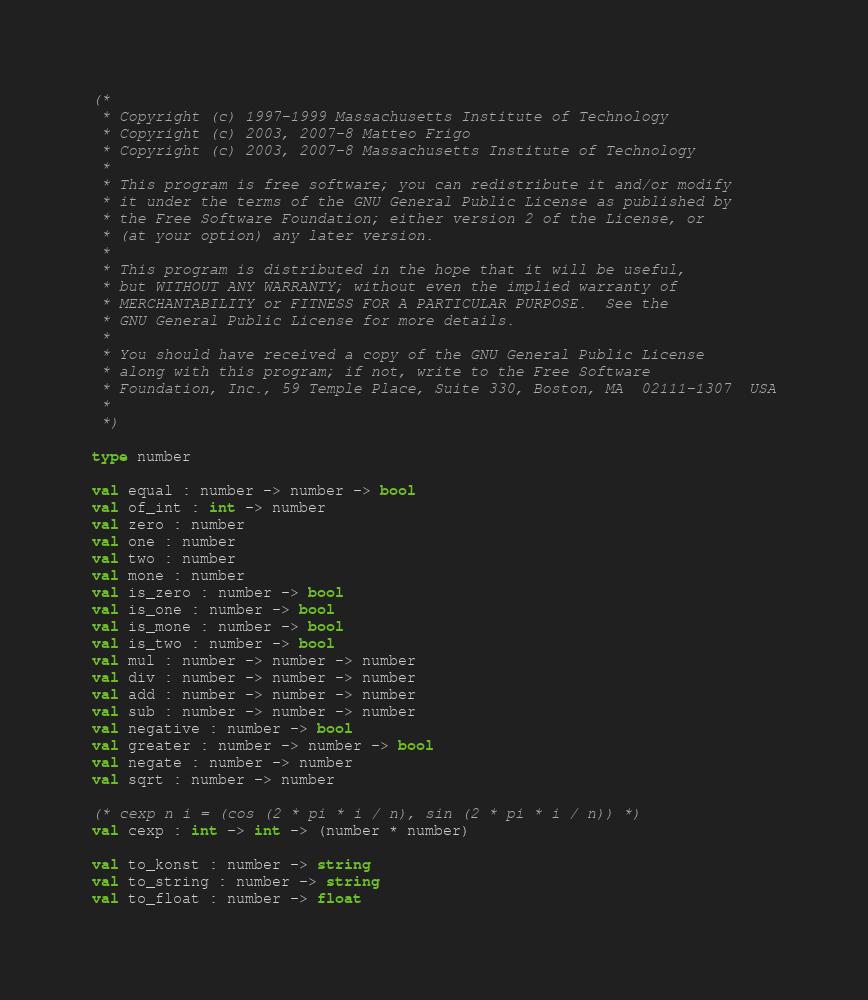Convert code to text. <code><loc_0><loc_0><loc_500><loc_500><_OCaml_>(*
 * Copyright (c) 1997-1999 Massachusetts Institute of Technology
 * Copyright (c) 2003, 2007-8 Matteo Frigo
 * Copyright (c) 2003, 2007-8 Massachusetts Institute of Technology
 *
 * This program is free software; you can redistribute it and/or modify
 * it under the terms of the GNU General Public License as published by
 * the Free Software Foundation; either version 2 of the License, or
 * (at your option) any later version.
 *
 * This program is distributed in the hope that it will be useful,
 * but WITHOUT ANY WARRANTY; without even the implied warranty of
 * MERCHANTABILITY or FITNESS FOR A PARTICULAR PURPOSE.  See the
 * GNU General Public License for more details.
 *
 * You should have received a copy of the GNU General Public License
 * along with this program; if not, write to the Free Software
 * Foundation, Inc., 59 Temple Place, Suite 330, Boston, MA  02111-1307  USA
 *
 *)

type number

val equal : number -> number -> bool
val of_int : int -> number
val zero : number
val one : number
val two : number
val mone : number
val is_zero : number -> bool
val is_one : number -> bool
val is_mone : number -> bool
val is_two : number -> bool
val mul : number -> number -> number
val div : number -> number -> number
val add : number -> number -> number
val sub : number -> number -> number
val negative : number -> bool
val greater : number -> number -> bool
val negate : number -> number
val sqrt : number -> number

(* cexp n i = (cos (2 * pi * i / n), sin (2 * pi * i / n)) *)
val cexp : int -> int -> (number * number)

val to_konst : number -> string
val to_string : number -> string
val to_float : number -> float

</code> 